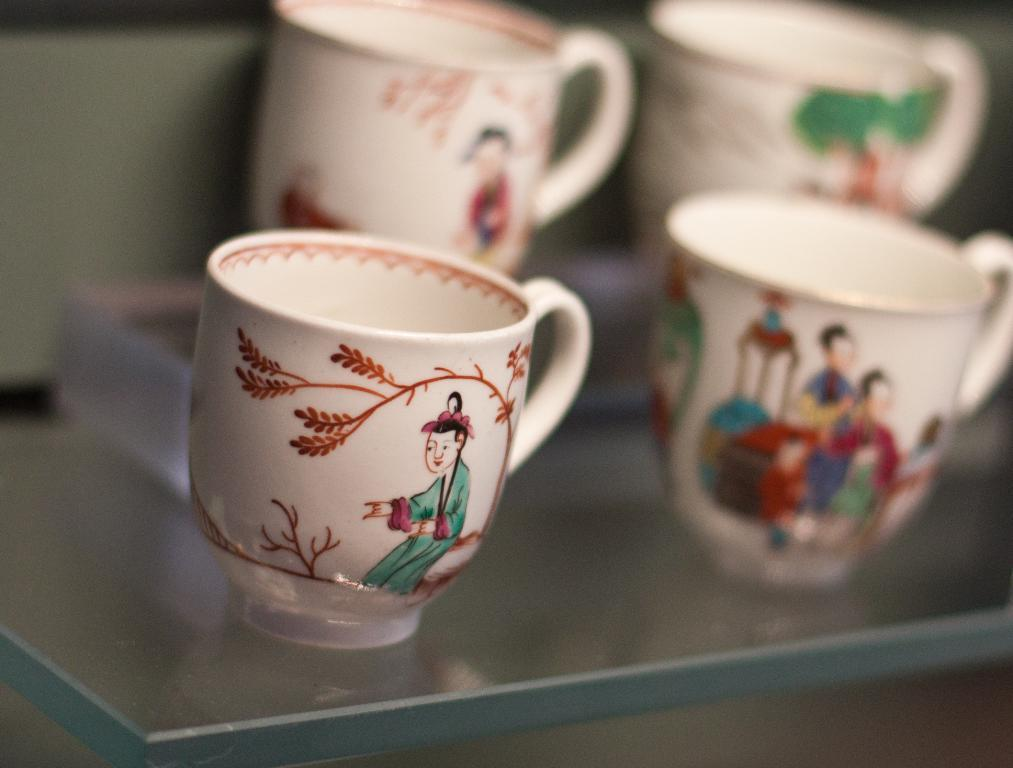What objects are visible in the image? There are cups in the image. What is the surface on which the cups are placed? The cups are on a glass surface. Can you describe the background of the image? The background of the image is blurred. Can you see any steam coming from the cups in the image? There is no indication of steam coming from the cups in the image. What type of cellar is visible beneath the glass surface in the image? There is no cellar visible in the image; it only shows cups on a glass surface with a blurred background. 